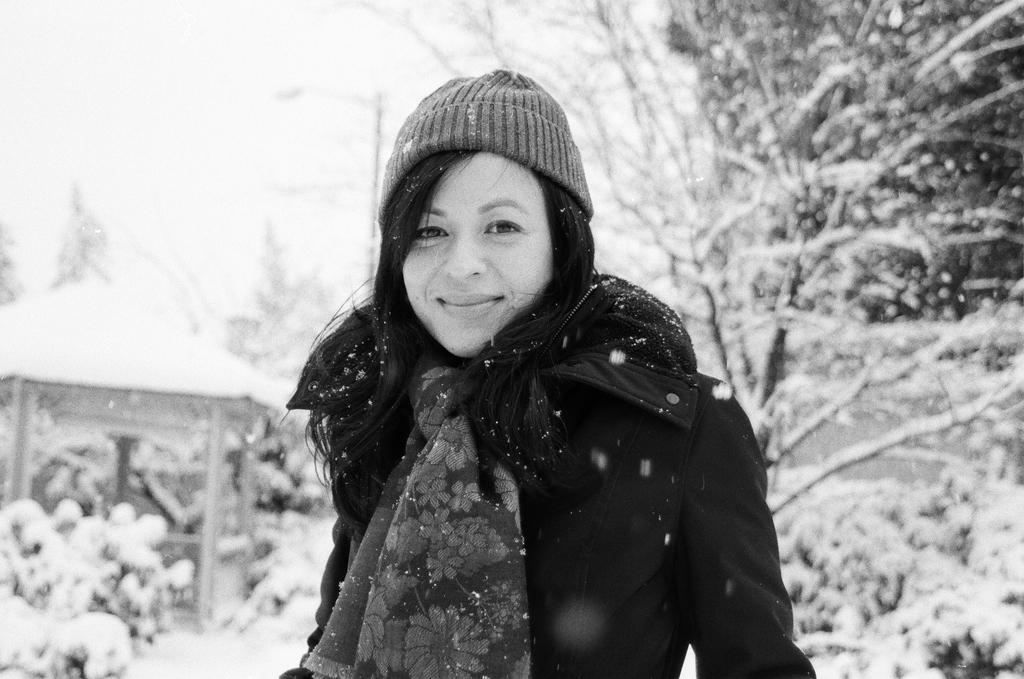What is the color scheme of the image? The image is black and white. Who is present in the image? There is a woman in the image. What is the woman wearing? The woman is wearing a jacket and cap. Where is the woman positioned in the image? The woman is standing in the middle of the image. What can be seen in the background of the image? There are trees on either side of the woman. What is the weather like in the image? There is snow in the image, indicating a cold or wintery setting. What type of shock can be seen affecting the woman in the image? There is no shock present in the image; the woman is standing calmly. Can you see any ghosts interacting with the woman in the image? There are no ghosts present in the image; it features a woman standing in the snow. 